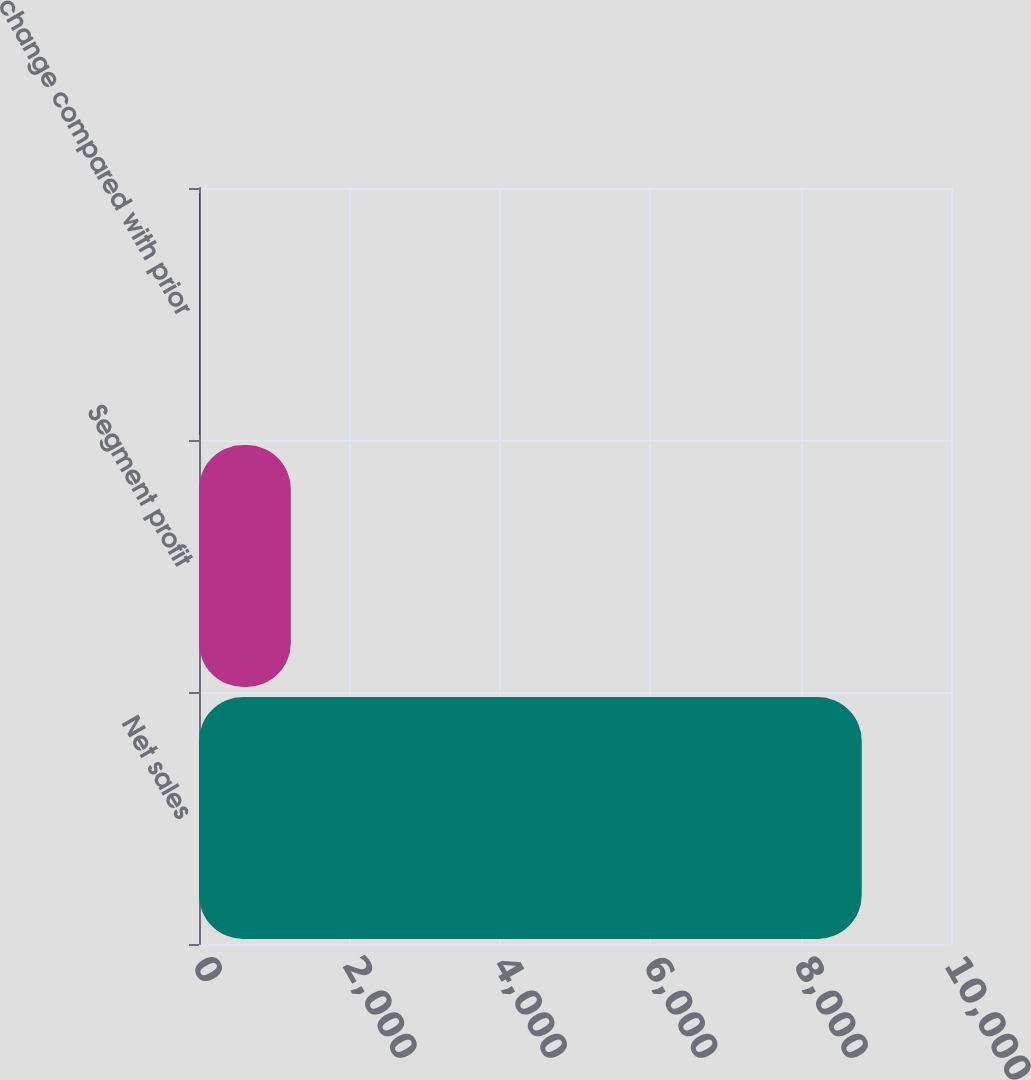<chart> <loc_0><loc_0><loc_500><loc_500><bar_chart><fcel>Net sales<fcel>Segment profit<fcel>change compared with prior<nl><fcel>8813<fcel>1221<fcel>7<nl></chart> 